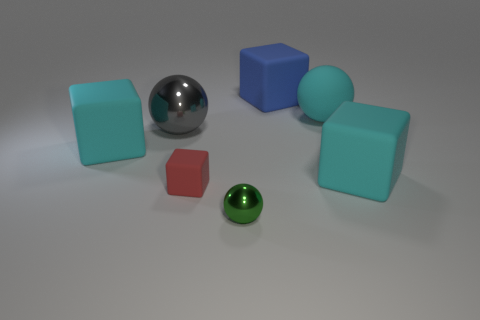Subtract all metal balls. How many balls are left? 1 Subtract all green spheres. How many spheres are left? 2 Subtract all blocks. How many objects are left? 3 Subtract 1 balls. How many balls are left? 2 Add 1 red rubber things. How many objects exist? 8 Subtract all blue blocks. Subtract all red cylinders. How many blocks are left? 3 Subtract all cyan cubes. How many green spheres are left? 1 Subtract all blue matte cylinders. Subtract all cyan spheres. How many objects are left? 6 Add 7 tiny shiny balls. How many tiny shiny balls are left? 8 Add 4 blue blocks. How many blue blocks exist? 5 